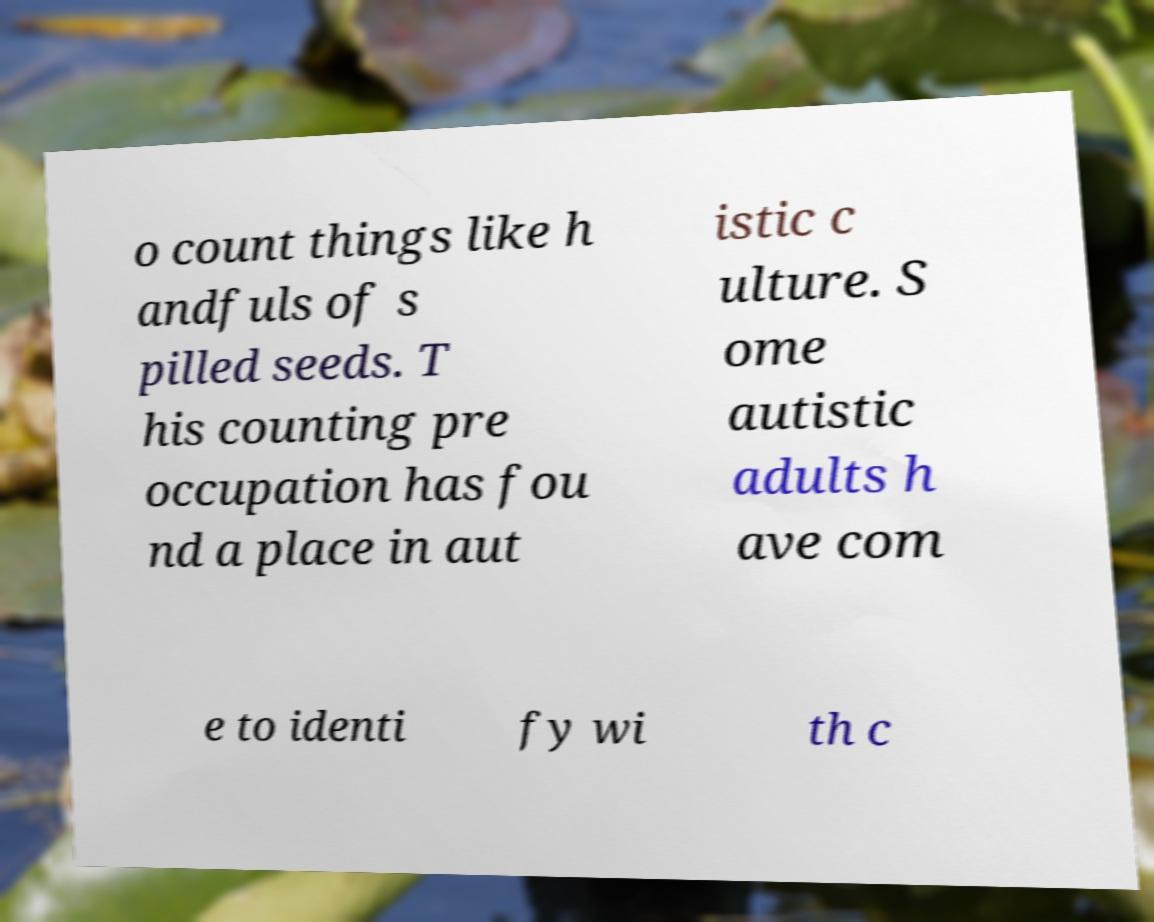Please read and relay the text visible in this image. What does it say? o count things like h andfuls of s pilled seeds. T his counting pre occupation has fou nd a place in aut istic c ulture. S ome autistic adults h ave com e to identi fy wi th c 